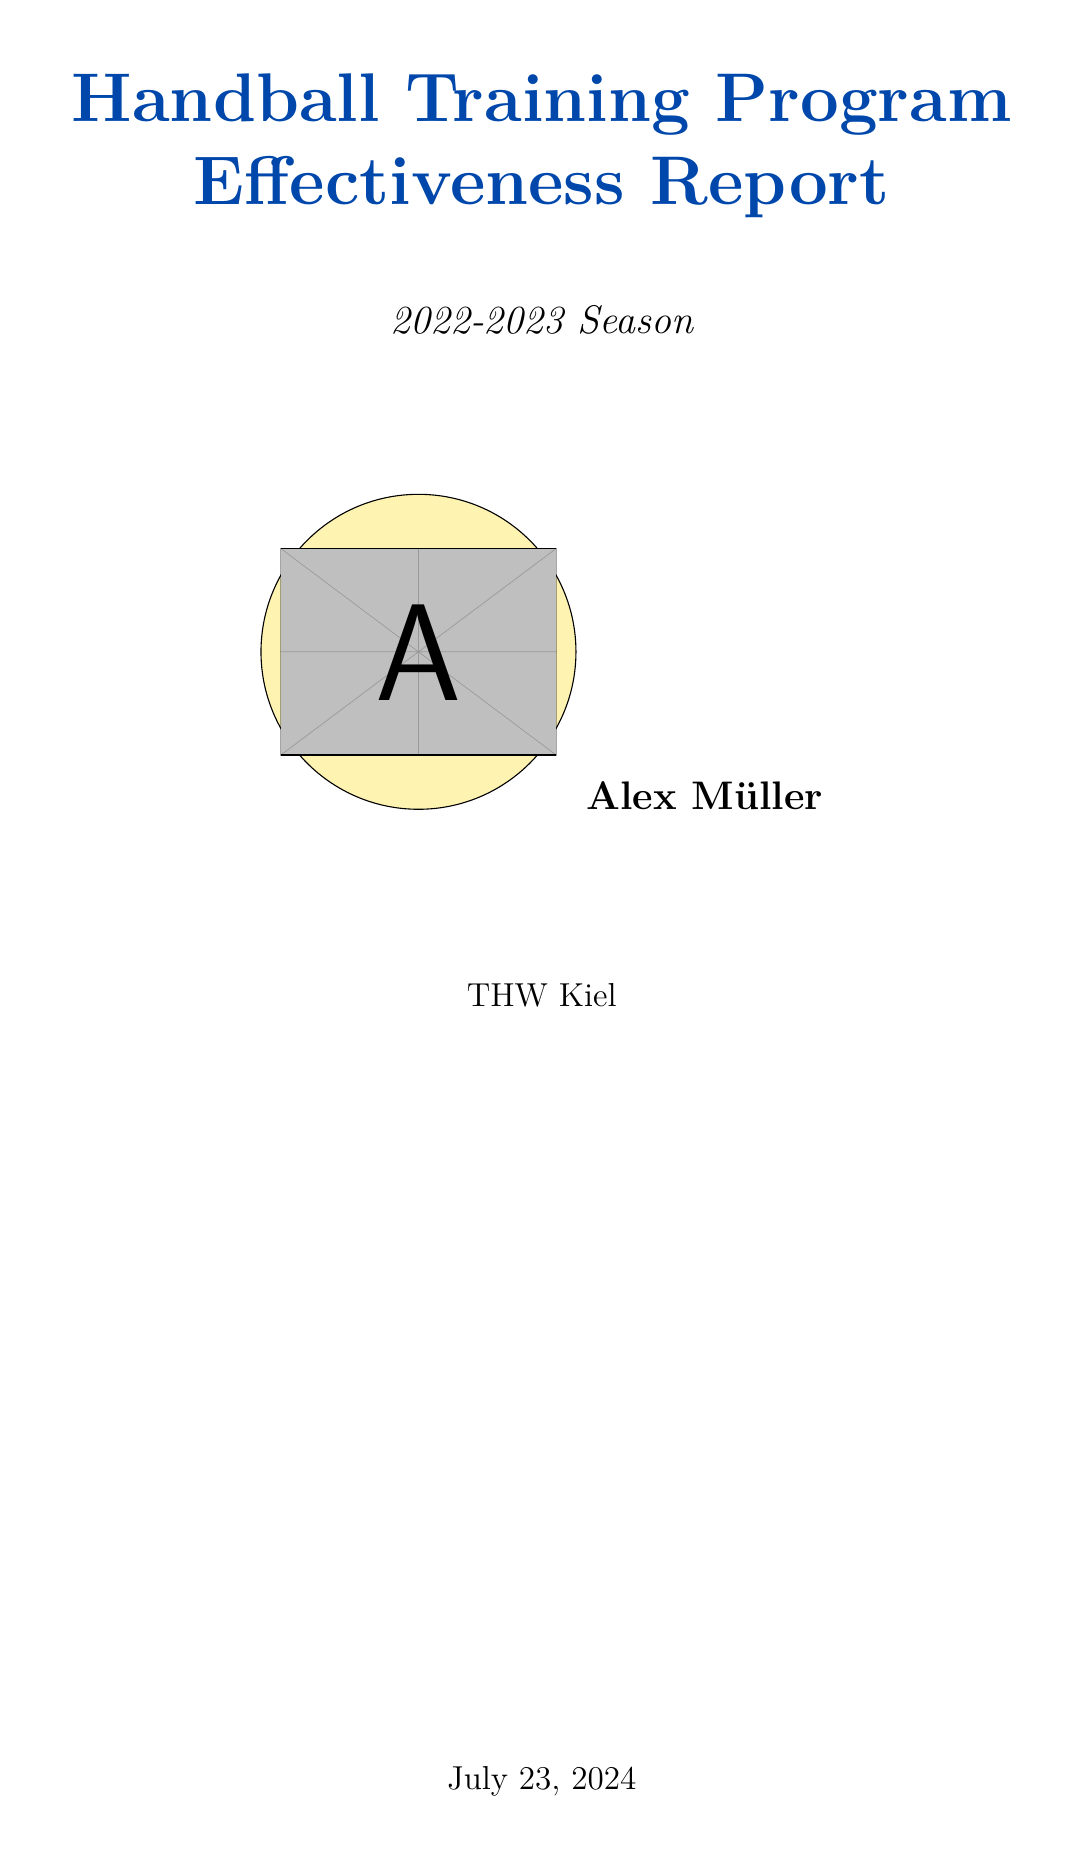What is the player's name? The player's name is stated in the report, which is Alex Müller.
Answer: Alex Müller What was the target value for shooting accuracy? The target value for shooting accuracy is specified in the pre-season goals section, which is 75.
Answer: 75 What was the actual average assists per game achieved? The actual average assists per game is mentioned in the actual progress section, which is 5.8.
Answer: 5.8 How many total injuries were reported during the season? The total number of injuries is provided in the injury report section, which states there were 2 injuries.
Answer: 2 What is the suggested impact of incorporating virtual reality training? The expected impact of incorporating virtual reality training is detailed in the suggested adjustments, which indicates an improvement of 5% in shooting accuracy.
Answer: Improve accuracy by 5% next season What does the coach identify as a strength observed in the player? The coach's feedback includes strengths, one of which is exceptional court vision.
Answer: Exceptional court vision What is the league position of the team? The league position of the team is given in the team performance section, which is 2.
Answer: 2 What is the pre-season average for goals scored per game? The pre-season average for goals scored per game can be found in the key performance indicators table, which states 5.2.
Answer: 5.2 What is one area the report suggests for improvement? One area suggested for improvement as per the report is consistency in long-range shooting.
Answer: Consistency in long-range shooting 